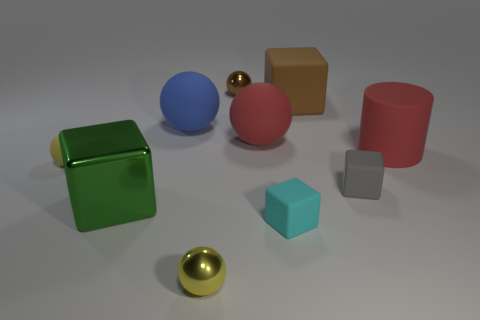What materials do the objects in the image seem to be made of? The objects exhibit different material qualities suggesting a variety of textures. The green and brown cubes along with the pink cylinder have a matte appearance, hinting at a possibly plastic or painted wooden material. The blue sphere, the smaller golden sphere, and the smaller silver cube have reflective surfaces, which could imply metallic or polished characteristics. 